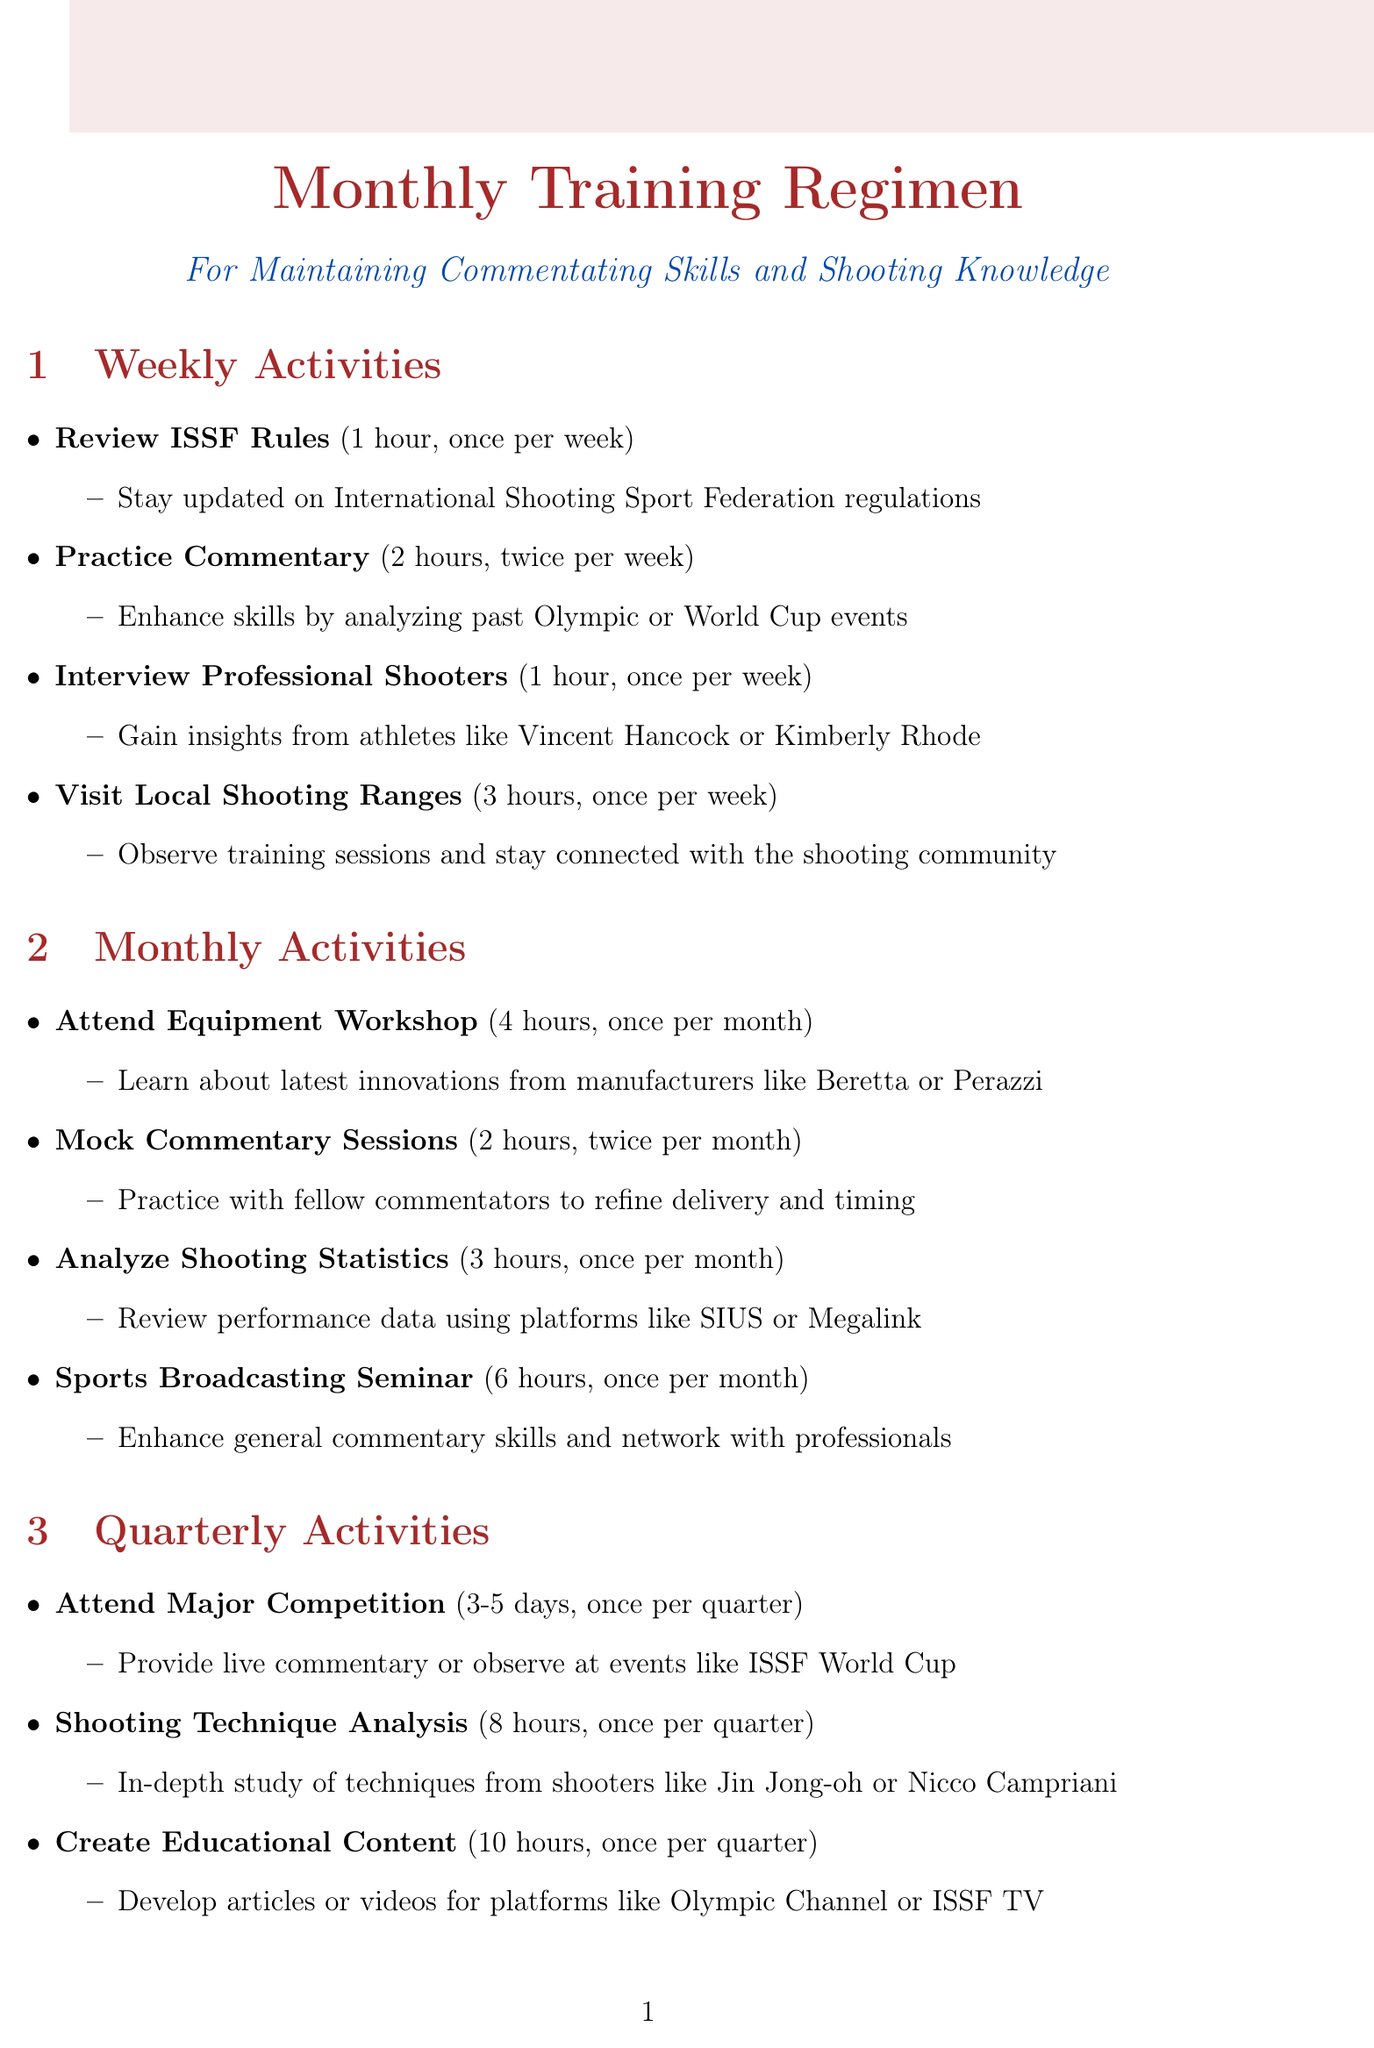What is the duration of the mock commentary sessions? The duration for mock commentary sessions is mentioned as 2 hours for each session, taking place twice a month.
Answer: 2 hours How often does one need to attend the shooting equipment workshop? The schedule states that the shooting equipment workshop occurs once per month, making it a monthly activity.
Answer: Once per month What is the frequency of the shooting technique analysis? The document specifies that shooting technique analysis is conducted once per quarter as part of the quarterly activities.
Answer: Once per quarter How many hours are allocated for the sports broadcasting seminar? The activity details describe the sports broadcasting seminar as having a duration of 6 hours.
Answer: 6 hours Who is suggested to be interviewed as part of the weekly activities? The schedule indicates interviewing professional shooters like Vincent Hancock or Kimberly Rhode to gain insights.
Answer: Professional shooters What is the total duration of the activities conducted annually? The annual activities include a judges course for 5 days, a workshop for 3 days, and a performance review for 4 hours, totaling 5 days + 3 days + 4 hours.
Answer: 5 days and 3 days How many hours do participants spend analyzing shooting statistics? The document specifies that participants spend 3 hours analyzing shooting statistics as a monthly activity.
Answer: 3 hours What type of commentary practice is emphasized in the monthly activities? The document highlights participating in mock commentary sessions as a key practice for improving commentary skills.
Answer: Mock commentary sessions What is the primary purpose of the annual performance review? The document states that the annual performance review is meant to analyze personal growth, set goals, and plan for improvement.
Answer: Analyze personal growth 